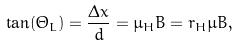<formula> <loc_0><loc_0><loc_500><loc_500>\tan ( \Theta _ { L } ) = \frac { \Delta x } { d } = \mu _ { H } B = r _ { H } \mu B ,</formula> 